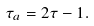<formula> <loc_0><loc_0><loc_500><loc_500>\tau _ { a } = 2 \tau - 1 .</formula> 